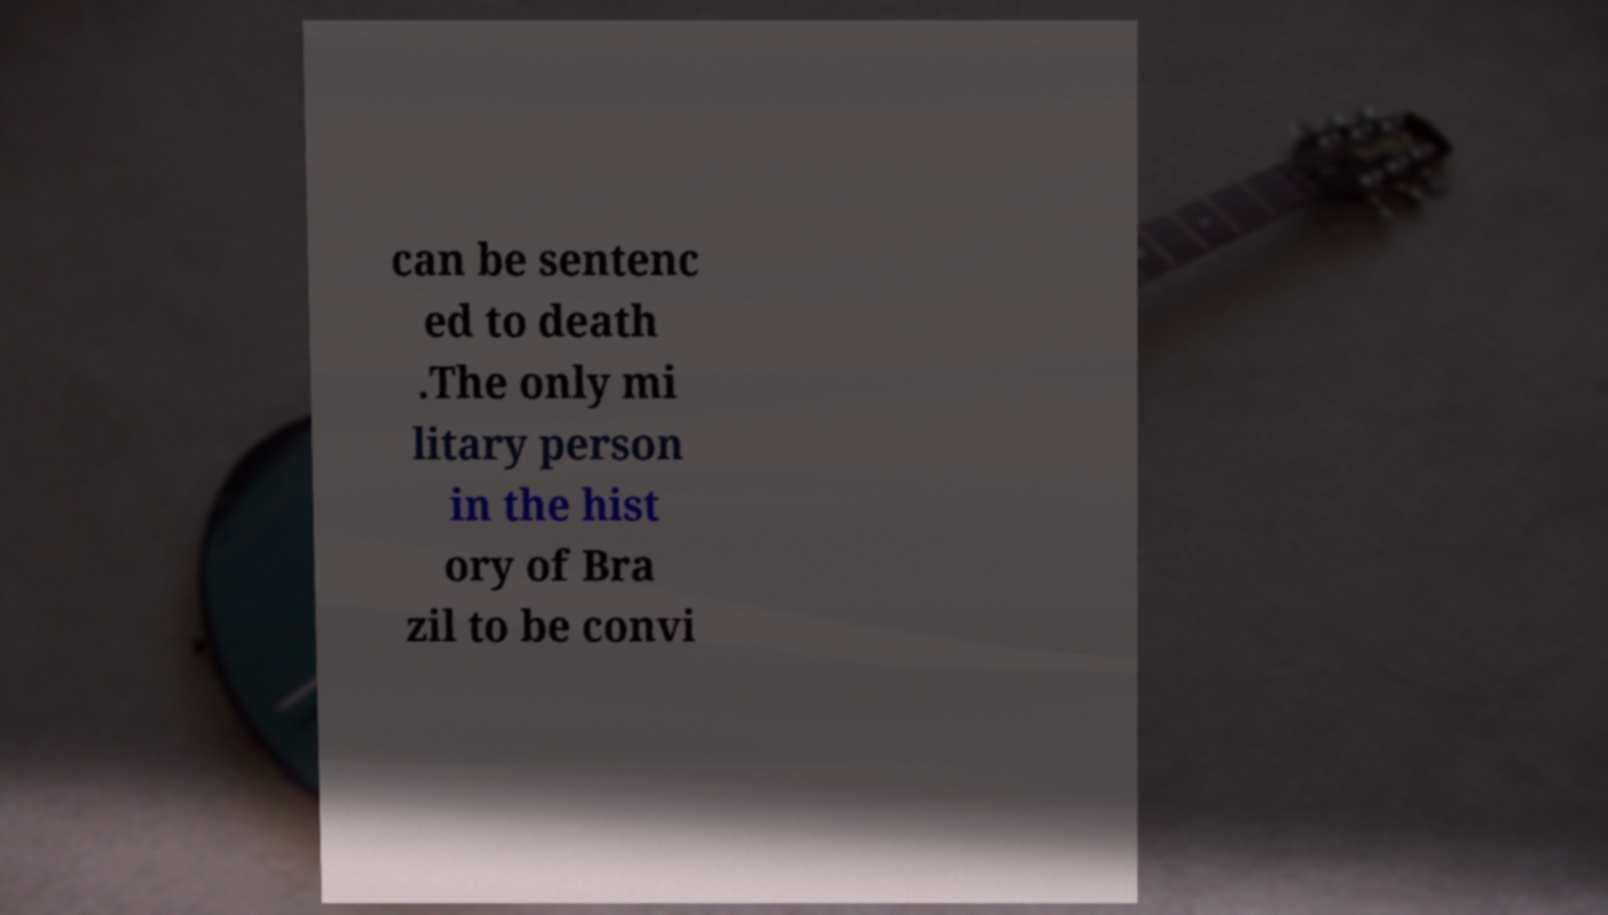Can you read and provide the text displayed in the image?This photo seems to have some interesting text. Can you extract and type it out for me? can be sentenc ed to death .The only mi litary person in the hist ory of Bra zil to be convi 